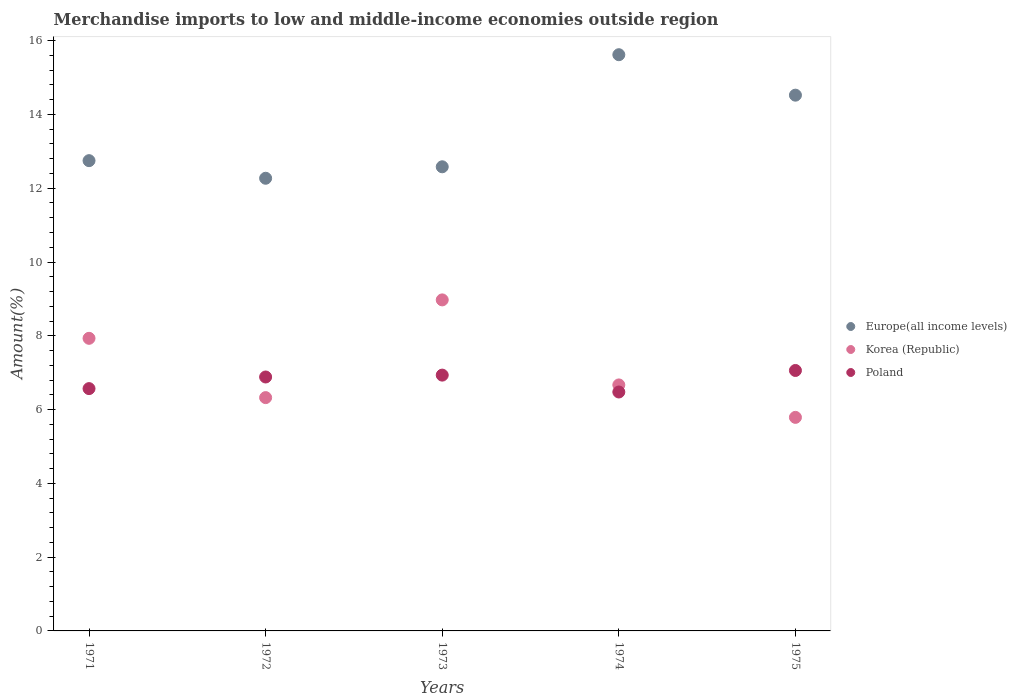What is the percentage of amount earned from merchandise imports in Poland in 1971?
Provide a short and direct response. 6.57. Across all years, what is the maximum percentage of amount earned from merchandise imports in Poland?
Your answer should be very brief. 7.06. Across all years, what is the minimum percentage of amount earned from merchandise imports in Europe(all income levels)?
Ensure brevity in your answer.  12.27. In which year was the percentage of amount earned from merchandise imports in Poland maximum?
Your response must be concise. 1975. In which year was the percentage of amount earned from merchandise imports in Korea (Republic) minimum?
Provide a succinct answer. 1975. What is the total percentage of amount earned from merchandise imports in Europe(all income levels) in the graph?
Offer a very short reply. 67.74. What is the difference between the percentage of amount earned from merchandise imports in Europe(all income levels) in 1972 and that in 1973?
Your answer should be compact. -0.31. What is the difference between the percentage of amount earned from merchandise imports in Korea (Republic) in 1973 and the percentage of amount earned from merchandise imports in Poland in 1971?
Keep it short and to the point. 2.4. What is the average percentage of amount earned from merchandise imports in Poland per year?
Make the answer very short. 6.78. In the year 1974, what is the difference between the percentage of amount earned from merchandise imports in Korea (Republic) and percentage of amount earned from merchandise imports in Europe(all income levels)?
Your answer should be compact. -8.95. In how many years, is the percentage of amount earned from merchandise imports in Europe(all income levels) greater than 12.8 %?
Provide a short and direct response. 2. What is the ratio of the percentage of amount earned from merchandise imports in Korea (Republic) in 1972 to that in 1975?
Your answer should be compact. 1.09. Is the percentage of amount earned from merchandise imports in Poland in 1972 less than that in 1973?
Keep it short and to the point. Yes. What is the difference between the highest and the second highest percentage of amount earned from merchandise imports in Europe(all income levels)?
Your response must be concise. 1.1. What is the difference between the highest and the lowest percentage of amount earned from merchandise imports in Europe(all income levels)?
Provide a short and direct response. 3.35. Is it the case that in every year, the sum of the percentage of amount earned from merchandise imports in Europe(all income levels) and percentage of amount earned from merchandise imports in Korea (Republic)  is greater than the percentage of amount earned from merchandise imports in Poland?
Give a very brief answer. Yes. How many years are there in the graph?
Make the answer very short. 5. Are the values on the major ticks of Y-axis written in scientific E-notation?
Your response must be concise. No. Does the graph contain any zero values?
Give a very brief answer. No. What is the title of the graph?
Your response must be concise. Merchandise imports to low and middle-income economies outside region. Does "Italy" appear as one of the legend labels in the graph?
Your answer should be very brief. No. What is the label or title of the Y-axis?
Your answer should be compact. Amount(%). What is the Amount(%) of Europe(all income levels) in 1971?
Make the answer very short. 12.75. What is the Amount(%) in Korea (Republic) in 1971?
Provide a succinct answer. 7.93. What is the Amount(%) of Poland in 1971?
Keep it short and to the point. 6.57. What is the Amount(%) of Europe(all income levels) in 1972?
Keep it short and to the point. 12.27. What is the Amount(%) of Korea (Republic) in 1972?
Your answer should be compact. 6.32. What is the Amount(%) of Poland in 1972?
Make the answer very short. 6.88. What is the Amount(%) in Europe(all income levels) in 1973?
Offer a very short reply. 12.58. What is the Amount(%) in Korea (Republic) in 1973?
Your answer should be compact. 8.97. What is the Amount(%) in Poland in 1973?
Keep it short and to the point. 6.93. What is the Amount(%) of Europe(all income levels) in 1974?
Make the answer very short. 15.62. What is the Amount(%) of Korea (Republic) in 1974?
Ensure brevity in your answer.  6.67. What is the Amount(%) in Poland in 1974?
Make the answer very short. 6.48. What is the Amount(%) in Europe(all income levels) in 1975?
Provide a short and direct response. 14.52. What is the Amount(%) in Korea (Republic) in 1975?
Offer a very short reply. 5.79. What is the Amount(%) in Poland in 1975?
Your answer should be compact. 7.06. Across all years, what is the maximum Amount(%) in Europe(all income levels)?
Offer a terse response. 15.62. Across all years, what is the maximum Amount(%) of Korea (Republic)?
Ensure brevity in your answer.  8.97. Across all years, what is the maximum Amount(%) in Poland?
Your answer should be very brief. 7.06. Across all years, what is the minimum Amount(%) of Europe(all income levels)?
Your response must be concise. 12.27. Across all years, what is the minimum Amount(%) of Korea (Republic)?
Keep it short and to the point. 5.79. Across all years, what is the minimum Amount(%) in Poland?
Your response must be concise. 6.48. What is the total Amount(%) in Europe(all income levels) in the graph?
Give a very brief answer. 67.74. What is the total Amount(%) in Korea (Republic) in the graph?
Offer a very short reply. 35.69. What is the total Amount(%) of Poland in the graph?
Offer a terse response. 33.92. What is the difference between the Amount(%) of Europe(all income levels) in 1971 and that in 1972?
Keep it short and to the point. 0.48. What is the difference between the Amount(%) of Korea (Republic) in 1971 and that in 1972?
Give a very brief answer. 1.61. What is the difference between the Amount(%) in Poland in 1971 and that in 1972?
Keep it short and to the point. -0.31. What is the difference between the Amount(%) in Europe(all income levels) in 1971 and that in 1973?
Keep it short and to the point. 0.17. What is the difference between the Amount(%) in Korea (Republic) in 1971 and that in 1973?
Your answer should be very brief. -1.04. What is the difference between the Amount(%) in Poland in 1971 and that in 1973?
Provide a short and direct response. -0.37. What is the difference between the Amount(%) in Europe(all income levels) in 1971 and that in 1974?
Offer a very short reply. -2.87. What is the difference between the Amount(%) in Korea (Republic) in 1971 and that in 1974?
Provide a short and direct response. 1.26. What is the difference between the Amount(%) of Poland in 1971 and that in 1974?
Make the answer very short. 0.09. What is the difference between the Amount(%) in Europe(all income levels) in 1971 and that in 1975?
Provide a succinct answer. -1.78. What is the difference between the Amount(%) in Korea (Republic) in 1971 and that in 1975?
Your answer should be very brief. 2.14. What is the difference between the Amount(%) of Poland in 1971 and that in 1975?
Ensure brevity in your answer.  -0.49. What is the difference between the Amount(%) of Europe(all income levels) in 1972 and that in 1973?
Provide a short and direct response. -0.31. What is the difference between the Amount(%) in Korea (Republic) in 1972 and that in 1973?
Ensure brevity in your answer.  -2.65. What is the difference between the Amount(%) of Poland in 1972 and that in 1973?
Provide a succinct answer. -0.05. What is the difference between the Amount(%) in Europe(all income levels) in 1972 and that in 1974?
Your response must be concise. -3.35. What is the difference between the Amount(%) of Korea (Republic) in 1972 and that in 1974?
Ensure brevity in your answer.  -0.34. What is the difference between the Amount(%) in Poland in 1972 and that in 1974?
Your answer should be compact. 0.41. What is the difference between the Amount(%) of Europe(all income levels) in 1972 and that in 1975?
Your answer should be compact. -2.25. What is the difference between the Amount(%) in Korea (Republic) in 1972 and that in 1975?
Your answer should be very brief. 0.54. What is the difference between the Amount(%) in Poland in 1972 and that in 1975?
Your answer should be compact. -0.18. What is the difference between the Amount(%) of Europe(all income levels) in 1973 and that in 1974?
Offer a terse response. -3.04. What is the difference between the Amount(%) of Korea (Republic) in 1973 and that in 1974?
Offer a terse response. 2.31. What is the difference between the Amount(%) of Poland in 1973 and that in 1974?
Provide a short and direct response. 0.46. What is the difference between the Amount(%) of Europe(all income levels) in 1973 and that in 1975?
Your answer should be very brief. -1.94. What is the difference between the Amount(%) in Korea (Republic) in 1973 and that in 1975?
Give a very brief answer. 3.18. What is the difference between the Amount(%) of Poland in 1973 and that in 1975?
Your answer should be very brief. -0.13. What is the difference between the Amount(%) in Europe(all income levels) in 1974 and that in 1975?
Provide a succinct answer. 1.1. What is the difference between the Amount(%) of Korea (Republic) in 1974 and that in 1975?
Make the answer very short. 0.88. What is the difference between the Amount(%) in Poland in 1974 and that in 1975?
Your answer should be compact. -0.58. What is the difference between the Amount(%) of Europe(all income levels) in 1971 and the Amount(%) of Korea (Republic) in 1972?
Ensure brevity in your answer.  6.42. What is the difference between the Amount(%) of Europe(all income levels) in 1971 and the Amount(%) of Poland in 1972?
Your response must be concise. 5.86. What is the difference between the Amount(%) in Korea (Republic) in 1971 and the Amount(%) in Poland in 1972?
Make the answer very short. 1.05. What is the difference between the Amount(%) in Europe(all income levels) in 1971 and the Amount(%) in Korea (Republic) in 1973?
Keep it short and to the point. 3.77. What is the difference between the Amount(%) in Europe(all income levels) in 1971 and the Amount(%) in Poland in 1973?
Give a very brief answer. 5.81. What is the difference between the Amount(%) in Korea (Republic) in 1971 and the Amount(%) in Poland in 1973?
Keep it short and to the point. 1. What is the difference between the Amount(%) in Europe(all income levels) in 1971 and the Amount(%) in Korea (Republic) in 1974?
Offer a very short reply. 6.08. What is the difference between the Amount(%) of Europe(all income levels) in 1971 and the Amount(%) of Poland in 1974?
Offer a very short reply. 6.27. What is the difference between the Amount(%) of Korea (Republic) in 1971 and the Amount(%) of Poland in 1974?
Provide a succinct answer. 1.46. What is the difference between the Amount(%) in Europe(all income levels) in 1971 and the Amount(%) in Korea (Republic) in 1975?
Provide a succinct answer. 6.96. What is the difference between the Amount(%) in Europe(all income levels) in 1971 and the Amount(%) in Poland in 1975?
Provide a short and direct response. 5.69. What is the difference between the Amount(%) of Korea (Republic) in 1971 and the Amount(%) of Poland in 1975?
Ensure brevity in your answer.  0.87. What is the difference between the Amount(%) in Europe(all income levels) in 1972 and the Amount(%) in Korea (Republic) in 1973?
Provide a short and direct response. 3.3. What is the difference between the Amount(%) of Europe(all income levels) in 1972 and the Amount(%) of Poland in 1973?
Your answer should be very brief. 5.34. What is the difference between the Amount(%) of Korea (Republic) in 1972 and the Amount(%) of Poland in 1973?
Provide a short and direct response. -0.61. What is the difference between the Amount(%) of Europe(all income levels) in 1972 and the Amount(%) of Korea (Republic) in 1974?
Your response must be concise. 5.6. What is the difference between the Amount(%) of Europe(all income levels) in 1972 and the Amount(%) of Poland in 1974?
Provide a succinct answer. 5.79. What is the difference between the Amount(%) in Korea (Republic) in 1972 and the Amount(%) in Poland in 1974?
Make the answer very short. -0.15. What is the difference between the Amount(%) of Europe(all income levels) in 1972 and the Amount(%) of Korea (Republic) in 1975?
Your answer should be compact. 6.48. What is the difference between the Amount(%) of Europe(all income levels) in 1972 and the Amount(%) of Poland in 1975?
Offer a terse response. 5.21. What is the difference between the Amount(%) of Korea (Republic) in 1972 and the Amount(%) of Poland in 1975?
Keep it short and to the point. -0.74. What is the difference between the Amount(%) of Europe(all income levels) in 1973 and the Amount(%) of Korea (Republic) in 1974?
Ensure brevity in your answer.  5.91. What is the difference between the Amount(%) of Europe(all income levels) in 1973 and the Amount(%) of Poland in 1974?
Provide a succinct answer. 6.1. What is the difference between the Amount(%) of Korea (Republic) in 1973 and the Amount(%) of Poland in 1974?
Keep it short and to the point. 2.5. What is the difference between the Amount(%) of Europe(all income levels) in 1973 and the Amount(%) of Korea (Republic) in 1975?
Give a very brief answer. 6.79. What is the difference between the Amount(%) in Europe(all income levels) in 1973 and the Amount(%) in Poland in 1975?
Make the answer very short. 5.52. What is the difference between the Amount(%) of Korea (Republic) in 1973 and the Amount(%) of Poland in 1975?
Offer a terse response. 1.91. What is the difference between the Amount(%) in Europe(all income levels) in 1974 and the Amount(%) in Korea (Republic) in 1975?
Make the answer very short. 9.83. What is the difference between the Amount(%) of Europe(all income levels) in 1974 and the Amount(%) of Poland in 1975?
Provide a succinct answer. 8.56. What is the difference between the Amount(%) in Korea (Republic) in 1974 and the Amount(%) in Poland in 1975?
Offer a very short reply. -0.39. What is the average Amount(%) of Europe(all income levels) per year?
Give a very brief answer. 13.55. What is the average Amount(%) of Korea (Republic) per year?
Ensure brevity in your answer.  7.14. What is the average Amount(%) of Poland per year?
Ensure brevity in your answer.  6.78. In the year 1971, what is the difference between the Amount(%) in Europe(all income levels) and Amount(%) in Korea (Republic)?
Provide a short and direct response. 4.82. In the year 1971, what is the difference between the Amount(%) in Europe(all income levels) and Amount(%) in Poland?
Offer a very short reply. 6.18. In the year 1971, what is the difference between the Amount(%) of Korea (Republic) and Amount(%) of Poland?
Provide a succinct answer. 1.36. In the year 1972, what is the difference between the Amount(%) of Europe(all income levels) and Amount(%) of Korea (Republic)?
Give a very brief answer. 5.95. In the year 1972, what is the difference between the Amount(%) in Europe(all income levels) and Amount(%) in Poland?
Provide a short and direct response. 5.39. In the year 1972, what is the difference between the Amount(%) of Korea (Republic) and Amount(%) of Poland?
Provide a succinct answer. -0.56. In the year 1973, what is the difference between the Amount(%) in Europe(all income levels) and Amount(%) in Korea (Republic)?
Your answer should be compact. 3.61. In the year 1973, what is the difference between the Amount(%) of Europe(all income levels) and Amount(%) of Poland?
Offer a very short reply. 5.65. In the year 1973, what is the difference between the Amount(%) in Korea (Republic) and Amount(%) in Poland?
Offer a terse response. 2.04. In the year 1974, what is the difference between the Amount(%) in Europe(all income levels) and Amount(%) in Korea (Republic)?
Your answer should be very brief. 8.95. In the year 1974, what is the difference between the Amount(%) of Europe(all income levels) and Amount(%) of Poland?
Make the answer very short. 9.14. In the year 1974, what is the difference between the Amount(%) in Korea (Republic) and Amount(%) in Poland?
Your response must be concise. 0.19. In the year 1975, what is the difference between the Amount(%) of Europe(all income levels) and Amount(%) of Korea (Republic)?
Offer a very short reply. 8.73. In the year 1975, what is the difference between the Amount(%) of Europe(all income levels) and Amount(%) of Poland?
Offer a very short reply. 7.46. In the year 1975, what is the difference between the Amount(%) of Korea (Republic) and Amount(%) of Poland?
Offer a terse response. -1.27. What is the ratio of the Amount(%) in Europe(all income levels) in 1971 to that in 1972?
Your answer should be compact. 1.04. What is the ratio of the Amount(%) of Korea (Republic) in 1971 to that in 1972?
Keep it short and to the point. 1.25. What is the ratio of the Amount(%) in Poland in 1971 to that in 1972?
Ensure brevity in your answer.  0.95. What is the ratio of the Amount(%) in Europe(all income levels) in 1971 to that in 1973?
Make the answer very short. 1.01. What is the ratio of the Amount(%) of Korea (Republic) in 1971 to that in 1973?
Your answer should be very brief. 0.88. What is the ratio of the Amount(%) in Poland in 1971 to that in 1973?
Offer a terse response. 0.95. What is the ratio of the Amount(%) of Europe(all income levels) in 1971 to that in 1974?
Make the answer very short. 0.82. What is the ratio of the Amount(%) in Korea (Republic) in 1971 to that in 1974?
Offer a terse response. 1.19. What is the ratio of the Amount(%) of Poland in 1971 to that in 1974?
Keep it short and to the point. 1.01. What is the ratio of the Amount(%) of Europe(all income levels) in 1971 to that in 1975?
Make the answer very short. 0.88. What is the ratio of the Amount(%) of Korea (Republic) in 1971 to that in 1975?
Your response must be concise. 1.37. What is the ratio of the Amount(%) in Poland in 1971 to that in 1975?
Provide a short and direct response. 0.93. What is the ratio of the Amount(%) of Europe(all income levels) in 1972 to that in 1973?
Ensure brevity in your answer.  0.98. What is the ratio of the Amount(%) in Korea (Republic) in 1972 to that in 1973?
Your answer should be compact. 0.7. What is the ratio of the Amount(%) in Poland in 1972 to that in 1973?
Your answer should be very brief. 0.99. What is the ratio of the Amount(%) in Europe(all income levels) in 1972 to that in 1974?
Ensure brevity in your answer.  0.79. What is the ratio of the Amount(%) of Korea (Republic) in 1972 to that in 1974?
Keep it short and to the point. 0.95. What is the ratio of the Amount(%) in Poland in 1972 to that in 1974?
Ensure brevity in your answer.  1.06. What is the ratio of the Amount(%) of Europe(all income levels) in 1972 to that in 1975?
Offer a terse response. 0.84. What is the ratio of the Amount(%) of Korea (Republic) in 1972 to that in 1975?
Ensure brevity in your answer.  1.09. What is the ratio of the Amount(%) in Europe(all income levels) in 1973 to that in 1974?
Offer a terse response. 0.81. What is the ratio of the Amount(%) in Korea (Republic) in 1973 to that in 1974?
Offer a very short reply. 1.35. What is the ratio of the Amount(%) of Poland in 1973 to that in 1974?
Provide a short and direct response. 1.07. What is the ratio of the Amount(%) of Europe(all income levels) in 1973 to that in 1975?
Ensure brevity in your answer.  0.87. What is the ratio of the Amount(%) of Korea (Republic) in 1973 to that in 1975?
Your answer should be very brief. 1.55. What is the ratio of the Amount(%) in Poland in 1973 to that in 1975?
Offer a terse response. 0.98. What is the ratio of the Amount(%) in Europe(all income levels) in 1974 to that in 1975?
Keep it short and to the point. 1.08. What is the ratio of the Amount(%) of Korea (Republic) in 1974 to that in 1975?
Your answer should be compact. 1.15. What is the ratio of the Amount(%) in Poland in 1974 to that in 1975?
Offer a terse response. 0.92. What is the difference between the highest and the second highest Amount(%) in Europe(all income levels)?
Provide a short and direct response. 1.1. What is the difference between the highest and the second highest Amount(%) of Korea (Republic)?
Your response must be concise. 1.04. What is the difference between the highest and the second highest Amount(%) of Poland?
Your answer should be compact. 0.13. What is the difference between the highest and the lowest Amount(%) of Europe(all income levels)?
Provide a succinct answer. 3.35. What is the difference between the highest and the lowest Amount(%) in Korea (Republic)?
Offer a very short reply. 3.18. What is the difference between the highest and the lowest Amount(%) of Poland?
Ensure brevity in your answer.  0.58. 